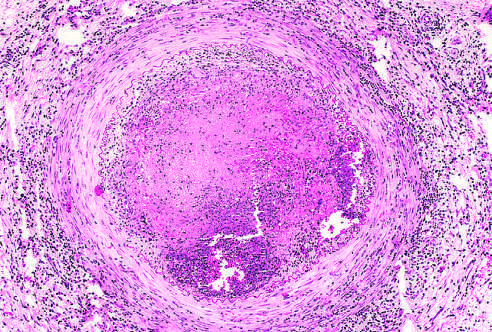what is infiltrated with leukocytes?
Answer the question using a single word or phrase. The vessel wall 